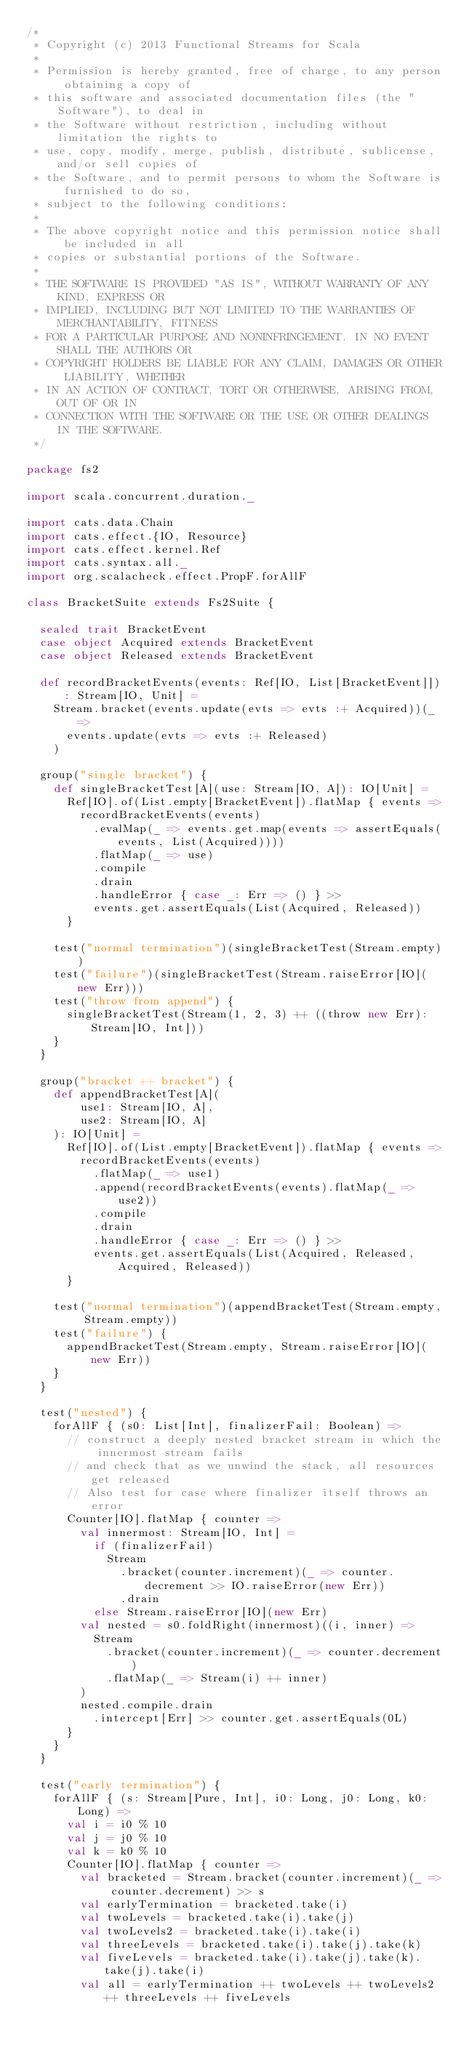<code> <loc_0><loc_0><loc_500><loc_500><_Scala_>/*
 * Copyright (c) 2013 Functional Streams for Scala
 *
 * Permission is hereby granted, free of charge, to any person obtaining a copy of
 * this software and associated documentation files (the "Software"), to deal in
 * the Software without restriction, including without limitation the rights to
 * use, copy, modify, merge, publish, distribute, sublicense, and/or sell copies of
 * the Software, and to permit persons to whom the Software is furnished to do so,
 * subject to the following conditions:
 *
 * The above copyright notice and this permission notice shall be included in all
 * copies or substantial portions of the Software.
 *
 * THE SOFTWARE IS PROVIDED "AS IS", WITHOUT WARRANTY OF ANY KIND, EXPRESS OR
 * IMPLIED, INCLUDING BUT NOT LIMITED TO THE WARRANTIES OF MERCHANTABILITY, FITNESS
 * FOR A PARTICULAR PURPOSE AND NONINFRINGEMENT. IN NO EVENT SHALL THE AUTHORS OR
 * COPYRIGHT HOLDERS BE LIABLE FOR ANY CLAIM, DAMAGES OR OTHER LIABILITY, WHETHER
 * IN AN ACTION OF CONTRACT, TORT OR OTHERWISE, ARISING FROM, OUT OF OR IN
 * CONNECTION WITH THE SOFTWARE OR THE USE OR OTHER DEALINGS IN THE SOFTWARE.
 */

package fs2

import scala.concurrent.duration._

import cats.data.Chain
import cats.effect.{IO, Resource}
import cats.effect.kernel.Ref
import cats.syntax.all._
import org.scalacheck.effect.PropF.forAllF

class BracketSuite extends Fs2Suite {

  sealed trait BracketEvent
  case object Acquired extends BracketEvent
  case object Released extends BracketEvent

  def recordBracketEvents(events: Ref[IO, List[BracketEvent]]): Stream[IO, Unit] =
    Stream.bracket(events.update(evts => evts :+ Acquired))(_ =>
      events.update(evts => evts :+ Released)
    )

  group("single bracket") {
    def singleBracketTest[A](use: Stream[IO, A]): IO[Unit] =
      Ref[IO].of(List.empty[BracketEvent]).flatMap { events =>
        recordBracketEvents(events)
          .evalMap(_ => events.get.map(events => assertEquals(events, List(Acquired))))
          .flatMap(_ => use)
          .compile
          .drain
          .handleError { case _: Err => () } >>
          events.get.assertEquals(List(Acquired, Released))
      }

    test("normal termination")(singleBracketTest(Stream.empty))
    test("failure")(singleBracketTest(Stream.raiseError[IO](new Err)))
    test("throw from append") {
      singleBracketTest(Stream(1, 2, 3) ++ ((throw new Err): Stream[IO, Int]))
    }
  }

  group("bracket ++ bracket") {
    def appendBracketTest[A](
        use1: Stream[IO, A],
        use2: Stream[IO, A]
    ): IO[Unit] =
      Ref[IO].of(List.empty[BracketEvent]).flatMap { events =>
        recordBracketEvents(events)
          .flatMap(_ => use1)
          .append(recordBracketEvents(events).flatMap(_ => use2))
          .compile
          .drain
          .handleError { case _: Err => () } >>
          events.get.assertEquals(List(Acquired, Released, Acquired, Released))
      }

    test("normal termination")(appendBracketTest(Stream.empty, Stream.empty))
    test("failure") {
      appendBracketTest(Stream.empty, Stream.raiseError[IO](new Err))
    }
  }

  test("nested") {
    forAllF { (s0: List[Int], finalizerFail: Boolean) =>
      // construct a deeply nested bracket stream in which the innermost stream fails
      // and check that as we unwind the stack, all resources get released
      // Also test for case where finalizer itself throws an error
      Counter[IO].flatMap { counter =>
        val innermost: Stream[IO, Int] =
          if (finalizerFail)
            Stream
              .bracket(counter.increment)(_ => counter.decrement >> IO.raiseError(new Err))
              .drain
          else Stream.raiseError[IO](new Err)
        val nested = s0.foldRight(innermost)((i, inner) =>
          Stream
            .bracket(counter.increment)(_ => counter.decrement)
            .flatMap(_ => Stream(i) ++ inner)
        )
        nested.compile.drain
          .intercept[Err] >> counter.get.assertEquals(0L)
      }
    }
  }

  test("early termination") {
    forAllF { (s: Stream[Pure, Int], i0: Long, j0: Long, k0: Long) =>
      val i = i0 % 10
      val j = j0 % 10
      val k = k0 % 10
      Counter[IO].flatMap { counter =>
        val bracketed = Stream.bracket(counter.increment)(_ => counter.decrement) >> s
        val earlyTermination = bracketed.take(i)
        val twoLevels = bracketed.take(i).take(j)
        val twoLevels2 = bracketed.take(i).take(i)
        val threeLevels = bracketed.take(i).take(j).take(k)
        val fiveLevels = bracketed.take(i).take(j).take(k).take(j).take(i)
        val all = earlyTermination ++ twoLevels ++ twoLevels2 ++ threeLevels ++ fiveLevels</code> 